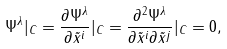<formula> <loc_0><loc_0><loc_500><loc_500>\Psi ^ { \lambda } | _ { C } = \frac { \partial \Psi ^ { \lambda } } { \partial \tilde { x } ^ { i } } | _ { C } = \frac { \partial ^ { 2 } \Psi ^ { \lambda } } { \partial \tilde { x } ^ { i } \partial \tilde { x } ^ { j } } | _ { C } = 0 ,</formula> 